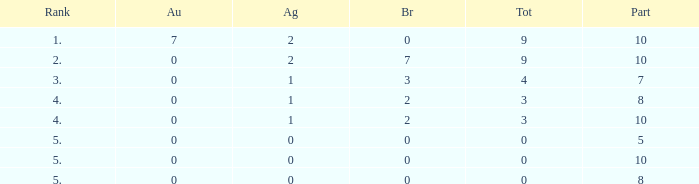What's the total Rank that has a Gold that's smaller than 0? None. 